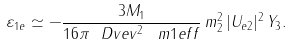Convert formula to latex. <formula><loc_0><loc_0><loc_500><loc_500>\varepsilon _ { 1 e } \simeq - \frac { 3 M _ { 1 } } { 1 6 \pi \ D v e v ^ { 2 } \, \ m 1 e f f } \, m _ { 2 } ^ { 2 } \, | U _ { e 2 } | ^ { 2 } \, Y _ { 3 } .</formula> 